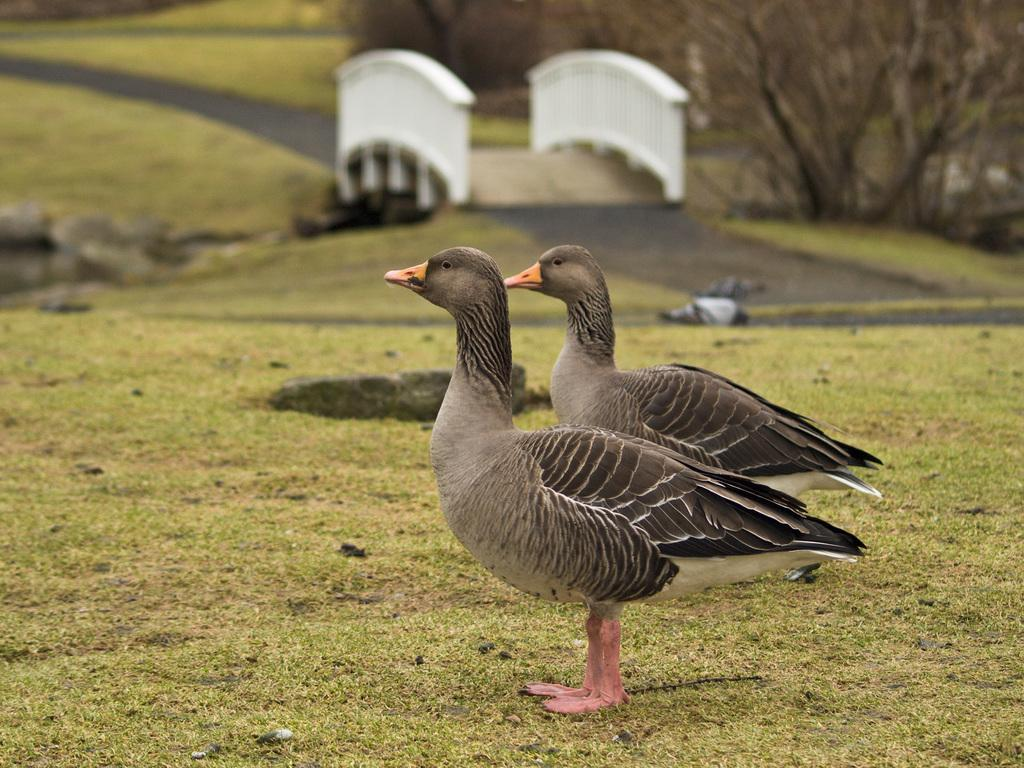How many birds are present in the image? There are two birds in the image. What colors are the birds? The birds are in black and gray colors. What can be seen in the background of the image? There is grass and dried trees visible in the background of the image. What color is the grass? The grass is green in color. What type of organization is the birds a part of in the image? There is no indication in the image that the birds are part of any organization. Can you tell me how many times the birds have crushed the dried trees in the image? There is no action of crushing depicted in the image; the birds are simply perched on the dried trees. 